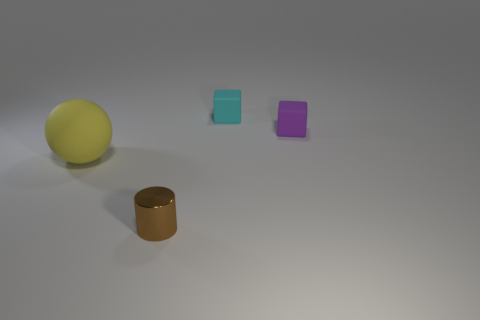Add 4 tiny gray rubber balls. How many objects exist? 8 Subtract all cylinders. How many objects are left? 3 Add 1 small cubes. How many small cubes are left? 3 Add 1 spheres. How many spheres exist? 2 Subtract 0 green cylinders. How many objects are left? 4 Subtract all spheres. Subtract all small blue rubber spheres. How many objects are left? 3 